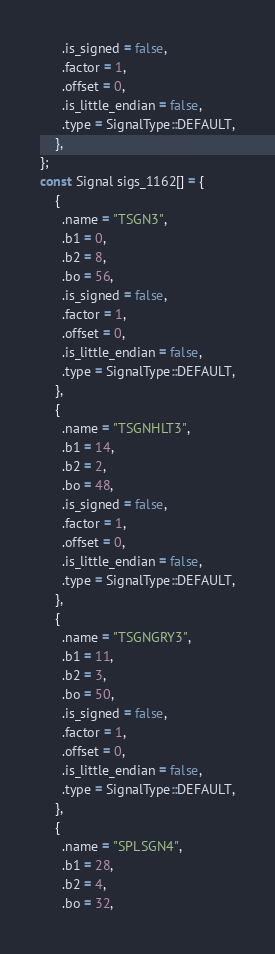<code> <loc_0><loc_0><loc_500><loc_500><_C++_>      .is_signed = false,
      .factor = 1,
      .offset = 0,
      .is_little_endian = false,
      .type = SignalType::DEFAULT,
    },
};
const Signal sigs_1162[] = {
    {
      .name = "TSGN3",
      .b1 = 0,
      .b2 = 8,
      .bo = 56,
      .is_signed = false,
      .factor = 1,
      .offset = 0,
      .is_little_endian = false,
      .type = SignalType::DEFAULT,
    },
    {
      .name = "TSGNHLT3",
      .b1 = 14,
      .b2 = 2,
      .bo = 48,
      .is_signed = false,
      .factor = 1,
      .offset = 0,
      .is_little_endian = false,
      .type = SignalType::DEFAULT,
    },
    {
      .name = "TSGNGRY3",
      .b1 = 11,
      .b2 = 3,
      .bo = 50,
      .is_signed = false,
      .factor = 1,
      .offset = 0,
      .is_little_endian = false,
      .type = SignalType::DEFAULT,
    },
    {
      .name = "SPLSGN4",
      .b1 = 28,
      .b2 = 4,
      .bo = 32,</code> 